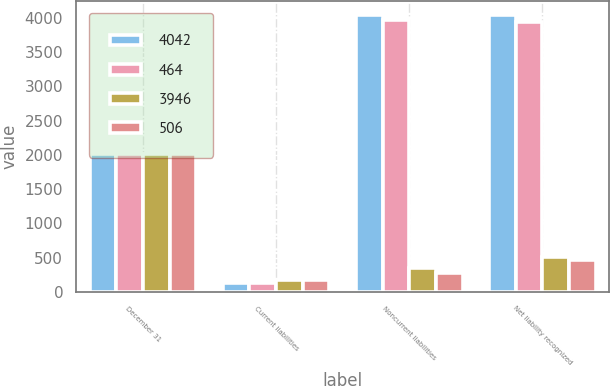Convert chart. <chart><loc_0><loc_0><loc_500><loc_500><stacked_bar_chart><ecel><fcel>December 31<fcel>Current liabilities<fcel>Noncurrent liabilities<fcel>Net liability recognized<nl><fcel>4042<fcel>2016<fcel>132<fcel>4048<fcel>4042<nl><fcel>464<fcel>2015<fcel>125<fcel>3966<fcel>3946<nl><fcel>3946<fcel>2016<fcel>171<fcel>345<fcel>506<nl><fcel>506<fcel>2015<fcel>179<fcel>285<fcel>464<nl></chart> 